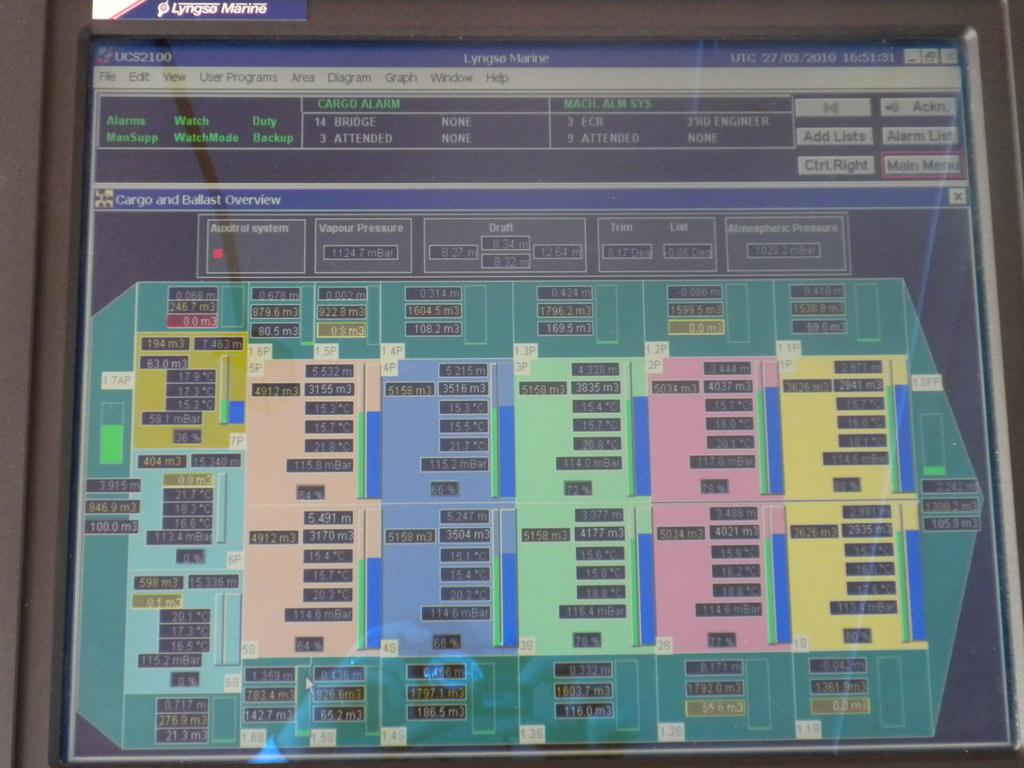Is this beer store?
Offer a terse response. Unanswerable. What does the computer screen say?
Keep it short and to the point. Cargo and ballast overview. 